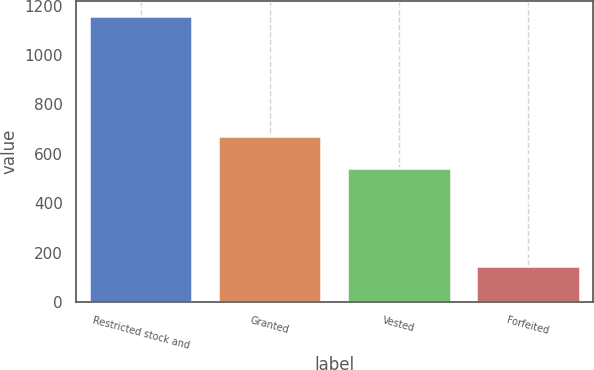<chart> <loc_0><loc_0><loc_500><loc_500><bar_chart><fcel>Restricted stock and<fcel>Granted<fcel>Vested<fcel>Forfeited<nl><fcel>1160<fcel>674<fcel>543<fcel>145<nl></chart> 